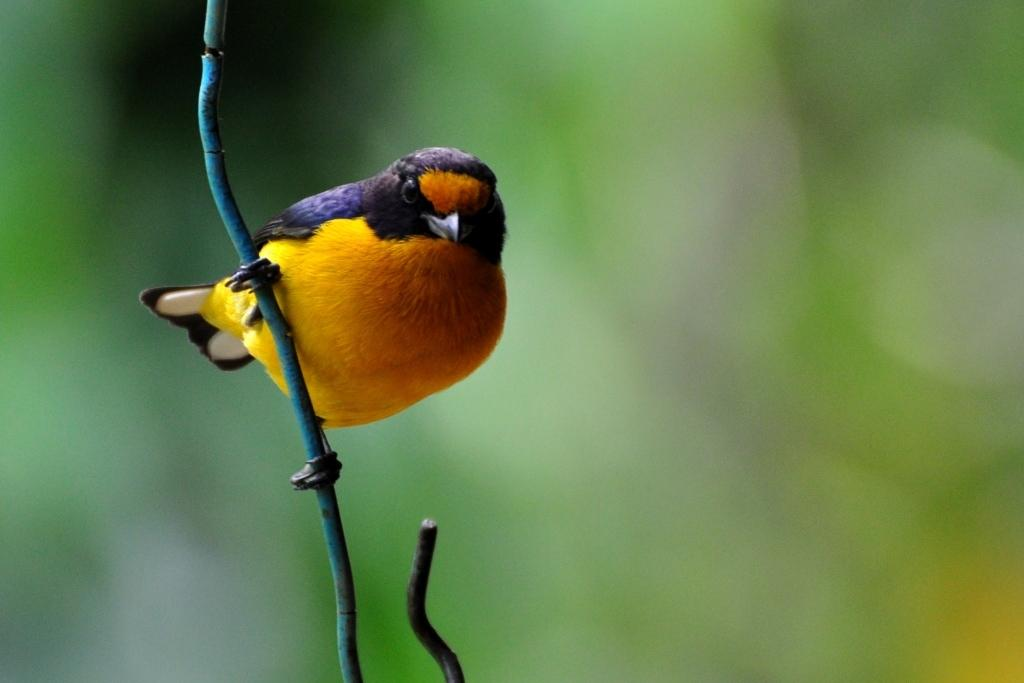What type of animal is in the image? There is a bird in the image. What is the bird standing on? The bird is standing on an iron object. Can you describe the background of the image? The background of the image is blurred and green. What finger does the bird use to hold the wrist in the image? There is no wrist or finger present in the image; it features a bird standing on an iron object with a blurred green background. 